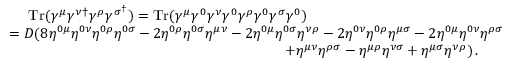<formula> <loc_0><loc_0><loc_500><loc_500>\begin{array} { r l } & { \quad \, T r ( \gamma ^ { \mu } \gamma ^ { \nu \dagger } \gamma ^ { \rho } \gamma ^ { \sigma ^ { \dagger } } ) = T r ( \gamma ^ { \mu } \gamma ^ { 0 } \gamma ^ { \nu } \gamma ^ { 0 } \gamma ^ { \rho } \gamma ^ { 0 } \gamma ^ { \sigma } \gamma ^ { 0 } ) } \\ & { = D ( 8 \eta ^ { 0 \mu } \eta ^ { 0 \nu } \eta ^ { 0 \rho } \eta ^ { 0 \sigma } - 2 \eta ^ { 0 \rho } \eta ^ { 0 \sigma } \eta ^ { \mu \nu } - 2 \eta ^ { 0 \mu } \eta ^ { 0 \sigma } \eta ^ { \nu \rho } - 2 \eta ^ { 0 \nu } \eta ^ { 0 \rho } \eta ^ { \mu \sigma } - 2 \eta ^ { 0 \mu } \eta ^ { 0 \nu } \eta ^ { \rho \sigma } } \\ & { \quad + \eta ^ { \mu \nu } \eta ^ { \rho \sigma } - \eta ^ { \mu \rho } \eta ^ { \nu \sigma } + \eta ^ { \mu \sigma } \eta ^ { \nu \rho } ) \, . } \end{array}</formula> 